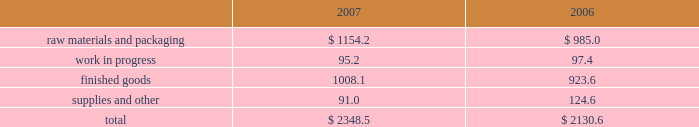Notes to consolidated financial statements 2014 ( continued ) fiscal years ended may 27 , 2007 , may 28 , 2006 , and may 29 , 2005 columnar amounts in millions except per share amounts 6 .
Impairment of debt and equity securities during fiscal 2005 , the company determined that the carrying values of its investments in two unrelated equity method investments , a bio-fuels venture and a malt venture , were other-than-temporarily impaired and therefore recognized pre-tax impairment charges totaling $ 71.0 million ( $ 65.6 million after tax ) .
During fiscal 2006 , the company recognized additional impairment charges totaling $ 75.8 million ( $ 73.1 million after tax ) of its investments in the malt venture and an unrelated investment in a foreign prepared foods business , due to further declines in the estimated proceeds from the disposition of these investments .
The investment in a foreign prepared foods business was disposed of in fiscal 2006 .
The extent of the impairments was determined based upon the company 2019s assessment of the recoverability of its investments based primarily upon the expected proceeds of planned dispositions of the investments .
During fiscal 2007 , the company completed the disposition of the equity method investment in the malt venture for proceeds of approximately $ 24 million , including notes and other receivables totaling approximately $ 7 million .
This transaction resulted in a pre-tax gain of approximately $ 4 million , with a related tax benefit of approximately $ 4 million .
These charges and the subsequent gain on disposition are reflected in equity method investment earnings ( loss ) in the consolidated statements of earnings .
The company held , at may 28 , 2006 , subordinated notes in the original principal amount of $ 150 million plus accrued interest of $ 50.4 million from swift foods .
During the company 2019s fourth quarter of fiscal 2005 , swift foods effected changes in its capital structure .
As a result of those changes , the company determined that the fair value of the subordinated notes was impaired .
From the date on which the company initially determined that the value of the notes was impaired through the second quarter of fiscal 2006 , the company believed the impairment of this available-for-sale security to be temporary .
As such , the company had reduced the carrying value of the note by $ 35.4 million and recorded cumulative after-tax charges of $ 21.9 million in accumulated other comprehensive income as of the end of the second quarter of fiscal 2006 .
During the second half of fiscal 2006 , due to the company 2019s consideration of current conditions related to the debtor 2019s business and changes in the company 2019s intended holding period for this investment , the company determined that the impairment was other-than-temporary .
Accordingly , the company reduced the carrying value of the notes to approximately $ 117 million and recognized impairment charges totaling $ 82.9 million in selling , general and administrative expenses , including the reclassification of the cumulative after-tax charges of $ 21.9 million from accumulated other comprehensive income , in fiscal 2006 .
During the second quarter of fiscal 2007 , the company closed on the sale of these notes for approximately $ 117 million , net of transaction expenses , resulting in no additional gain or loss .
Inventories the major classes of inventories are as follows: .
Raw materials and packaging includes grain , fertilizer , crude oil , and other trading and merchandising inventory of $ 691.0 million and $ 542.1 million as of the end of fiscal year 2007 and 2006 , respectively. .
What percent of total inventories was comprised of raw materials and packaging in 2007? 
Computations: (1154.2 / 2348.5)
Answer: 0.49146. 